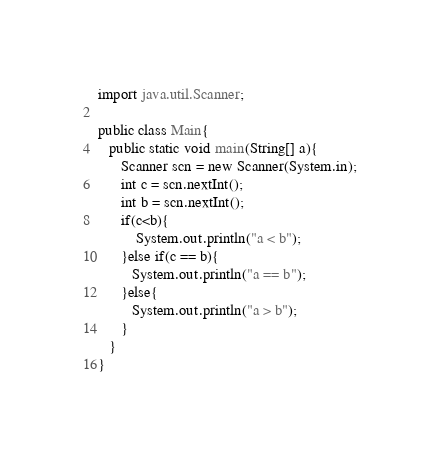Convert code to text. <code><loc_0><loc_0><loc_500><loc_500><_Java_>import java.util.Scanner;

public class Main{
   public static void main(String[] a){
      Scanner scn = new Scanner(System.in);
      int c = scn.nextInt();
      int b = scn.nextInt();
      if(c<b){
          System.out.println("a < b");
      }else if(c == b){
         System.out.println("a == b");
      }else{
         System.out.println("a > b");
      }
   }
}</code> 